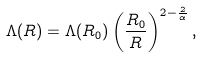Convert formula to latex. <formula><loc_0><loc_0><loc_500><loc_500>\Lambda ( R ) = \Lambda ( R _ { 0 } ) \left ( \frac { R _ { 0 } } { R } \right ) ^ { 2 - \frac { 2 } { \alpha } } ,</formula> 